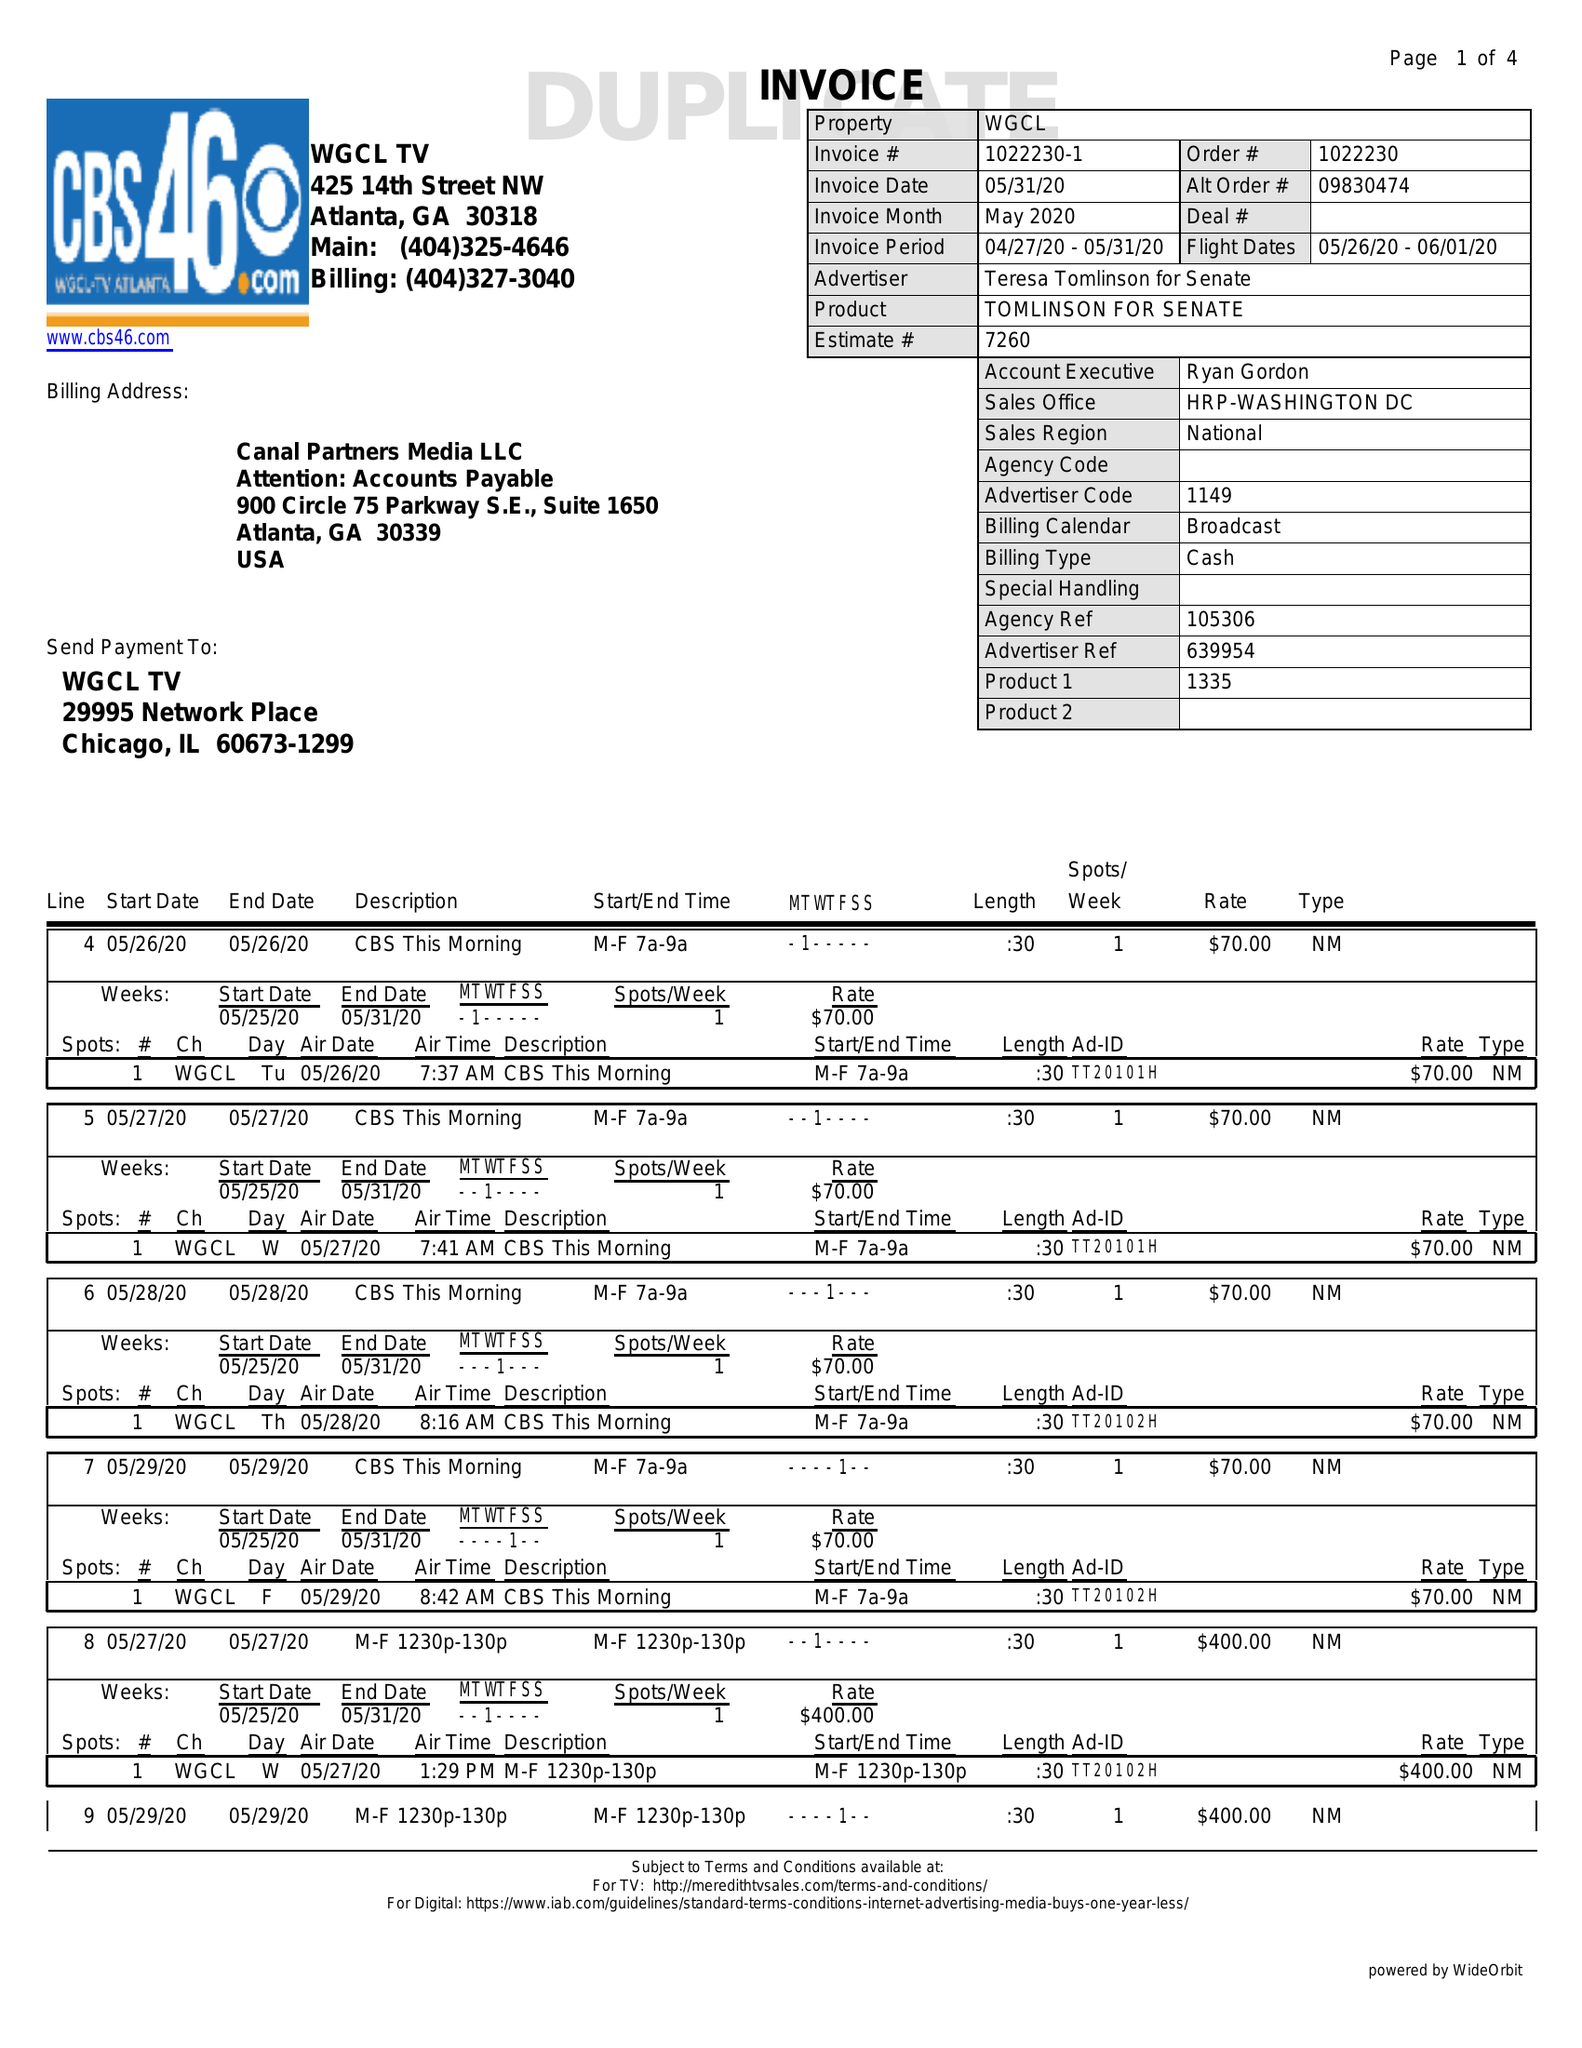What is the value for the flight_from?
Answer the question using a single word or phrase. 05/26/20 